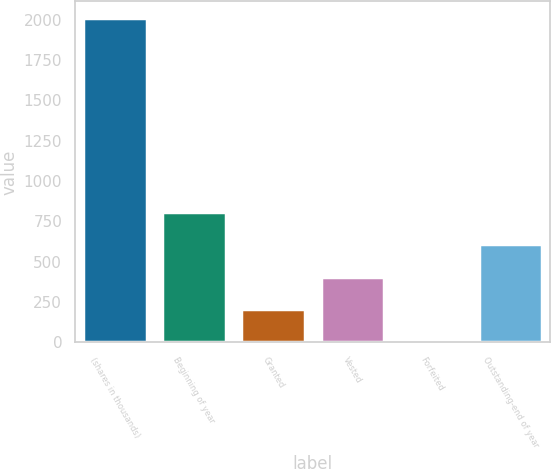<chart> <loc_0><loc_0><loc_500><loc_500><bar_chart><fcel>(shares in thousands)<fcel>Beginning of year<fcel>Granted<fcel>Vested<fcel>Forfeited<fcel>Outstanding-end of year<nl><fcel>2012<fcel>809<fcel>207.5<fcel>408<fcel>7<fcel>608.5<nl></chart> 